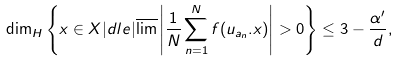Convert formula to latex. <formula><loc_0><loc_0><loc_500><loc_500>\dim _ { H } \left \{ x \in X | d l e | \overline { \lim } \left | \frac { 1 } { N } \sum _ { n = 1 } ^ { N } f ( u _ { a _ { n } } . x ) \right | > 0 \right \} \leq 3 - \frac { \alpha ^ { \prime } } { d } ,</formula> 